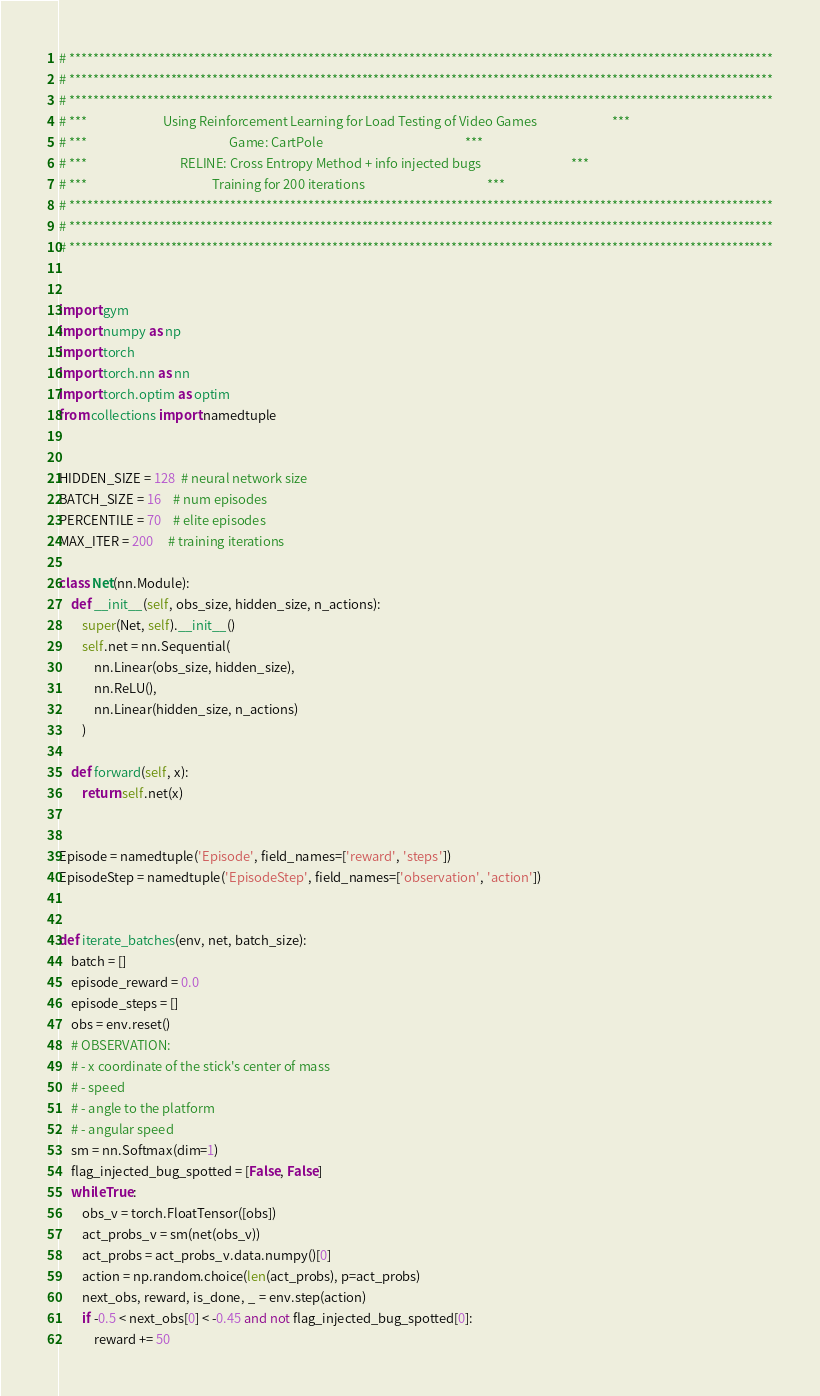Convert code to text. <code><loc_0><loc_0><loc_500><loc_500><_Python_># **********************************************************************************************************************
# **********************************************************************************************************************
# **********************************************************************************************************************
# ***                          Using Reinforcement Learning for Load Testing of Video Games                          ***
# ***                                                 Game: CartPole                                                 ***
# ***                                RELINE: Cross Entropy Method + info injected bugs                               ***
# ***                                           Training for 200 iterations                                          ***
# **********************************************************************************************************************
# **********************************************************************************************************************
# **********************************************************************************************************************


import gym
import numpy as np
import torch
import torch.nn as nn
import torch.optim as optim
from collections import namedtuple


HIDDEN_SIZE = 128  # neural network size
BATCH_SIZE = 16    # num episodes
PERCENTILE = 70    # elite episodes
MAX_ITER = 200     # training iterations

class Net(nn.Module):
    def __init__(self, obs_size, hidden_size, n_actions):
        super(Net, self).__init__()
        self.net = nn.Sequential(
            nn.Linear(obs_size, hidden_size),
            nn.ReLU(),
            nn.Linear(hidden_size, n_actions)
        )

    def forward(self, x):
        return self.net(x)


Episode = namedtuple('Episode', field_names=['reward', 'steps'])
EpisodeStep = namedtuple('EpisodeStep', field_names=['observation', 'action'])


def iterate_batches(env, net, batch_size):
    batch = []
    episode_reward = 0.0
    episode_steps = []
    obs = env.reset()
    # OBSERVATION:
    # - x coordinate of the stick's center of mass
    # - speed
    # - angle to the platform
    # - angular speed
    sm = nn.Softmax(dim=1)
    flag_injected_bug_spotted = [False, False]
    while True:
        obs_v = torch.FloatTensor([obs])
        act_probs_v = sm(net(obs_v))
        act_probs = act_probs_v.data.numpy()[0]
        action = np.random.choice(len(act_probs), p=act_probs)
        next_obs, reward, is_done, _ = env.step(action)
        if -0.5 < next_obs[0] < -0.45 and not flag_injected_bug_spotted[0]:
            reward += 50</code> 